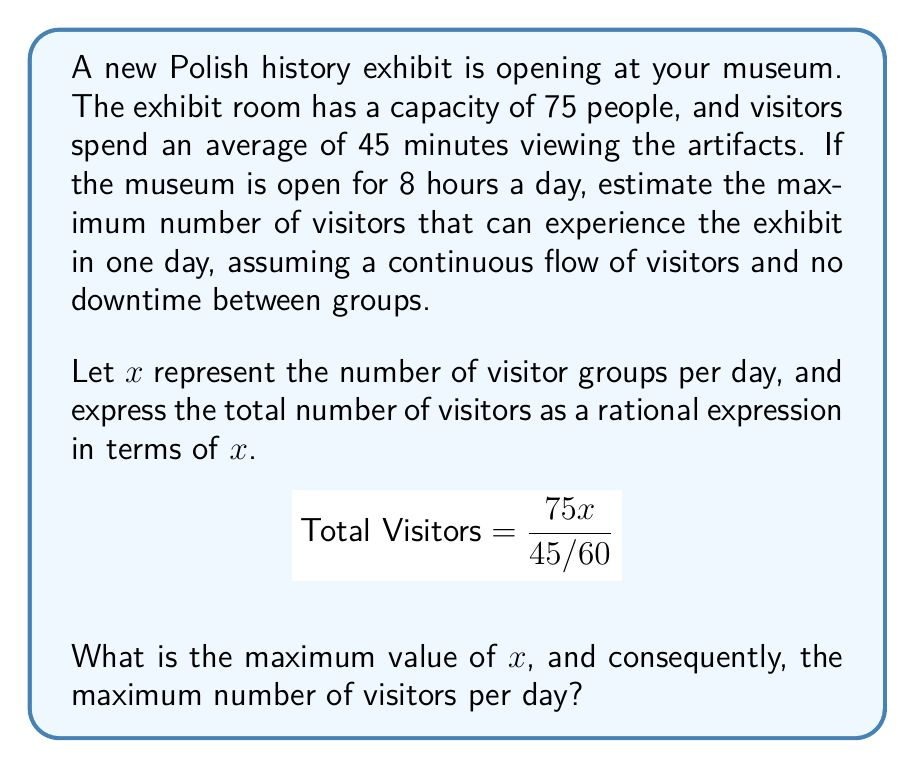Provide a solution to this math problem. Let's approach this step-by-step:

1) First, we need to understand what the rational expression represents:
   $$\text{Total Visitors} = \frac{75x}{45/60}$$
   Here, 75 is the room capacity, $x$ is the number of groups per day, and 45/60 (or 3/4) is the fraction of an hour each group spends in the exhibit.

2) To simplify this expression:
   $$\text{Total Visitors} = \frac{75x}{45/60} = \frac{75x}{\frac{3}{4}} = 75x \cdot \frac{4}{3} = 100x$$

3) Now, we need to find the maximum value of $x$. We know the museum is open for 8 hours a day, so:
   $$8 = \frac{45}{60}x$$
   $$8 = \frac{3}{4}x$$
   $$x = 8 \cdot \frac{4}{3} = \frac{32}{3} \approx 10.67$$

4) Since we can't have a fractional number of groups, we round down to 10 groups per day.

5) Therefore, the maximum number of visitors per day is:
   $$\text{Max Visitors} = 100 \cdot 10 = 1000$$
Answer: 1000 visitors per day 